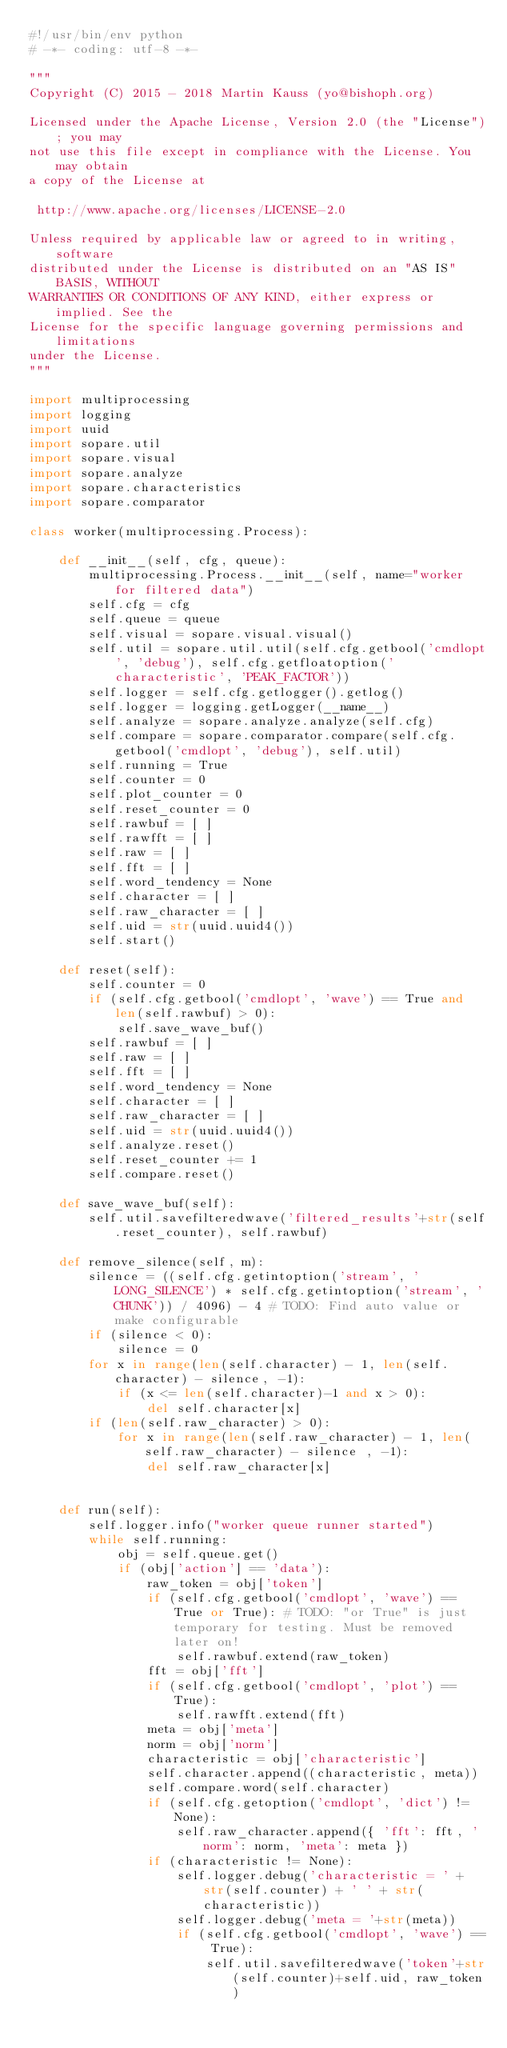Convert code to text. <code><loc_0><loc_0><loc_500><loc_500><_Python_>#!/usr/bin/env python
# -*- coding: utf-8 -*-

"""
Copyright (C) 2015 - 2018 Martin Kauss (yo@bishoph.org)

Licensed under the Apache License, Version 2.0 (the "License"); you may
not use this file except in compliance with the License. You may obtain
a copy of the License at

 http://www.apache.org/licenses/LICENSE-2.0

Unless required by applicable law or agreed to in writing, software
distributed under the License is distributed on an "AS IS" BASIS, WITHOUT
WARRANTIES OR CONDITIONS OF ANY KIND, either express or implied. See the
License for the specific language governing permissions and limitations
under the License.
"""

import multiprocessing
import logging
import uuid
import sopare.util
import sopare.visual
import sopare.analyze
import sopare.characteristics
import sopare.comparator

class worker(multiprocessing.Process):

    def __init__(self, cfg, queue):
        multiprocessing.Process.__init__(self, name="worker for filtered data")
        self.cfg = cfg
        self.queue = queue
        self.visual = sopare.visual.visual()
        self.util = sopare.util.util(self.cfg.getbool('cmdlopt', 'debug'), self.cfg.getfloatoption('characteristic', 'PEAK_FACTOR'))
        self.logger = self.cfg.getlogger().getlog()
        self.logger = logging.getLogger(__name__)
        self.analyze = sopare.analyze.analyze(self.cfg)
        self.compare = sopare.comparator.compare(self.cfg.getbool('cmdlopt', 'debug'), self.util)
        self.running = True
        self.counter = 0
        self.plot_counter = 0
        self.reset_counter = 0
        self.rawbuf = [ ]
        self.rawfft = [ ]
        self.raw = [ ]
        self.fft = [ ]
        self.word_tendency = None
        self.character = [ ]
        self.raw_character = [ ]
        self.uid = str(uuid.uuid4())
        self.start()

    def reset(self):
        self.counter = 0
        if (self.cfg.getbool('cmdlopt', 'wave') == True and len(self.rawbuf) > 0):
            self.save_wave_buf()
        self.rawbuf = [ ]
        self.raw = [ ]
        self.fft = [ ]
        self.word_tendency = None
        self.character = [ ]
        self.raw_character = [ ]
        self.uid = str(uuid.uuid4())
        self.analyze.reset()
        self.reset_counter += 1
        self.compare.reset()

    def save_wave_buf(self):
        self.util.savefilteredwave('filtered_results'+str(self.reset_counter), self.rawbuf)

    def remove_silence(self, m):
        silence = ((self.cfg.getintoption('stream', 'LONG_SILENCE') * self.cfg.getintoption('stream', 'CHUNK')) / 4096) - 4 # TODO: Find auto value or make configurable
        if (silence < 0):
            silence = 0
        for x in range(len(self.character) - 1, len(self.character) - silence, -1):
            if (x <= len(self.character)-1 and x > 0):
                del self.character[x]
        if (len(self.raw_character) > 0):
            for x in range(len(self.raw_character) - 1, len(self.raw_character) - silence , -1):
                del self.raw_character[x]


    def run(self):
        self.logger.info("worker queue runner started")
        while self.running:
            obj = self.queue.get()
            if (obj['action'] == 'data'):
                raw_token = obj['token']
                if (self.cfg.getbool('cmdlopt', 'wave') == True or True): # TODO: "or True" is just temporary for testing. Must be removed later on!
                    self.rawbuf.extend(raw_token)
                fft = obj['fft']
                if (self.cfg.getbool('cmdlopt', 'plot') == True):
                    self.rawfft.extend(fft)
                meta = obj['meta']
                norm = obj['norm']
                characteristic = obj['characteristic']
                self.character.append((characteristic, meta))
                self.compare.word(self.character)
                if (self.cfg.getoption('cmdlopt', 'dict') != None):
                    self.raw_character.append({ 'fft': fft, 'norm': norm, 'meta': meta })
                if (characteristic != None):
                    self.logger.debug('characteristic = ' + str(self.counter) + ' ' + str(characteristic))
                    self.logger.debug('meta = '+str(meta))
                    if (self.cfg.getbool('cmdlopt', 'wave') == True):
                        self.util.savefilteredwave('token'+str(self.counter)+self.uid, raw_token)</code> 